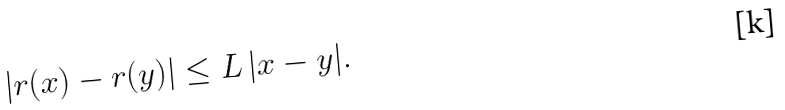Convert formula to latex. <formula><loc_0><loc_0><loc_500><loc_500>| r ( x ) - r ( y ) | \leq L \, | x - y | .</formula> 